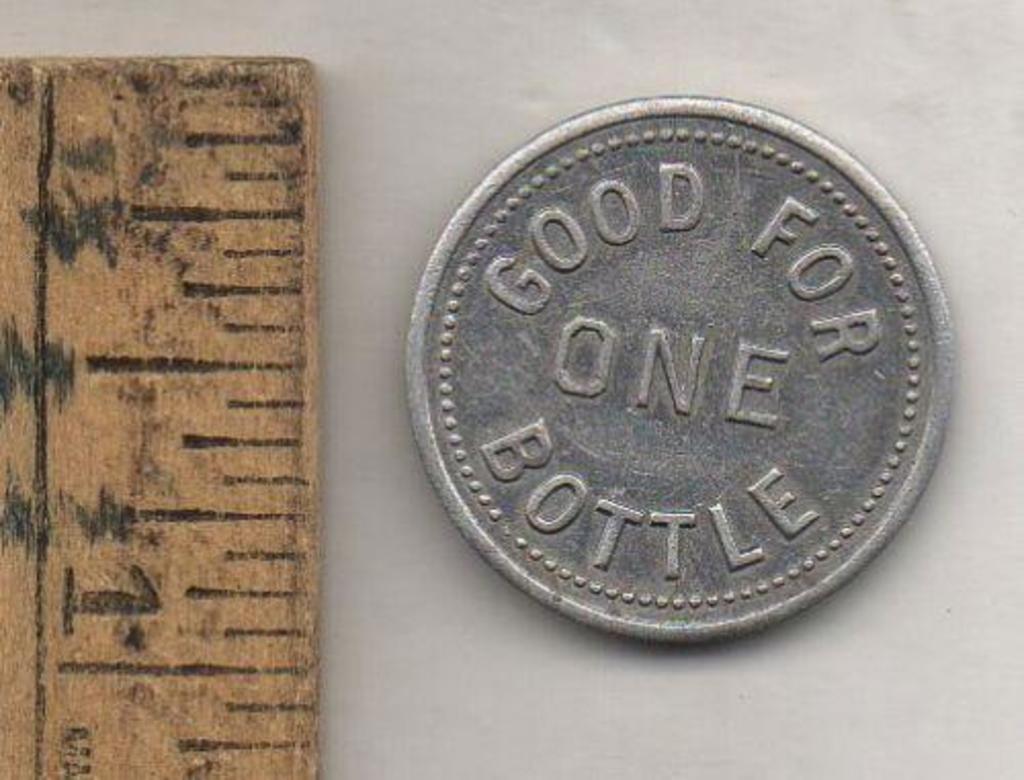How many bottle can you buy?
Offer a very short reply. One. What is written on the coin?
Your answer should be very brief. Good for one bottle. 